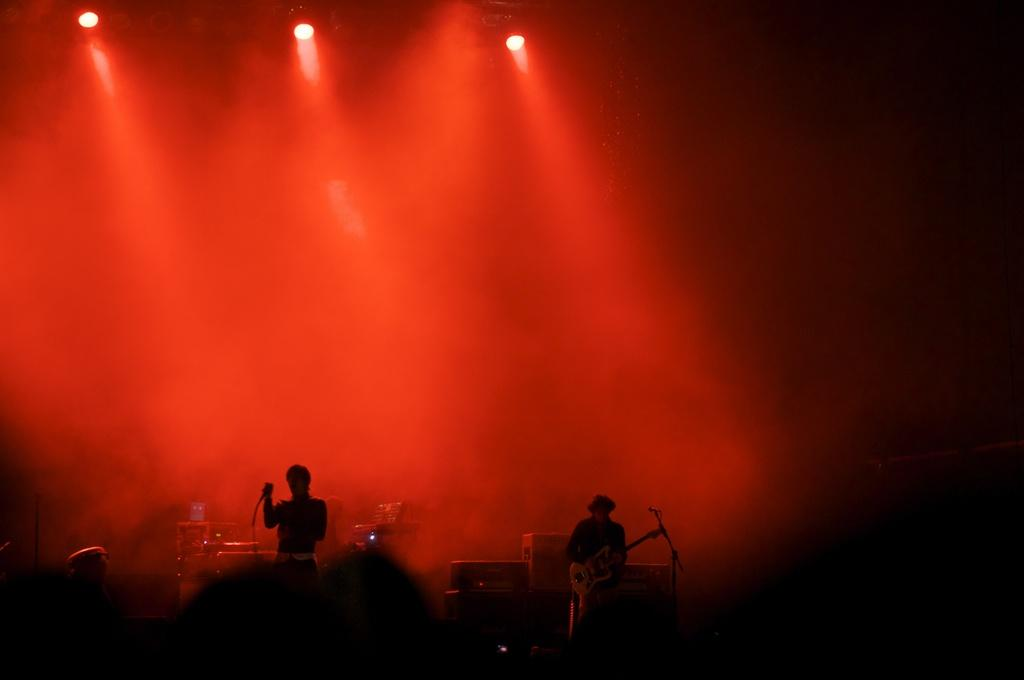How many people are in the image? There are people in the image, but the exact number is not specified. What are the people holding in the image? The people are holding objects in the image. What position are the people in? The people are standing in the image. What can be seen in the image that provides illumination? There are lights visible in the image. What is the color of the background in the image? The background of the image is dark. What type of ring can be seen on the person's finger in the image? There is no ring visible on any person's finger in the image. What is the person cooking in the oven in the image? There is no oven present in the image. 